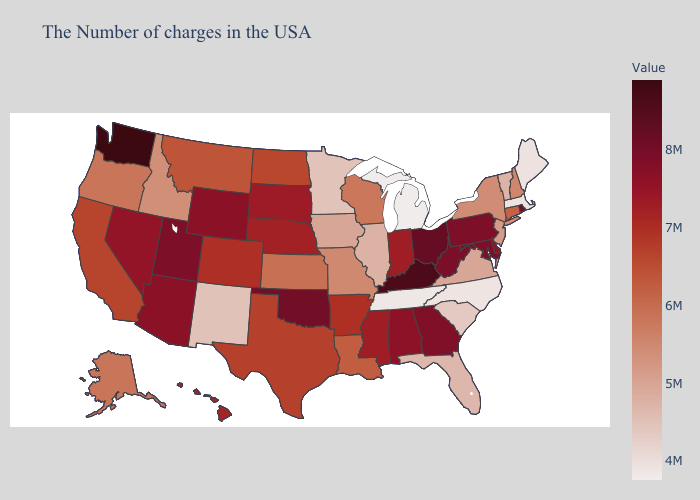Does Utah have a higher value than Washington?
Short answer required. No. Does Florida have a higher value than California?
Concise answer only. No. Does the map have missing data?
Give a very brief answer. No. Does New Mexico have the lowest value in the West?
Short answer required. Yes. Is the legend a continuous bar?
Concise answer only. Yes. Is the legend a continuous bar?
Keep it brief. Yes. Is the legend a continuous bar?
Answer briefly. Yes. 